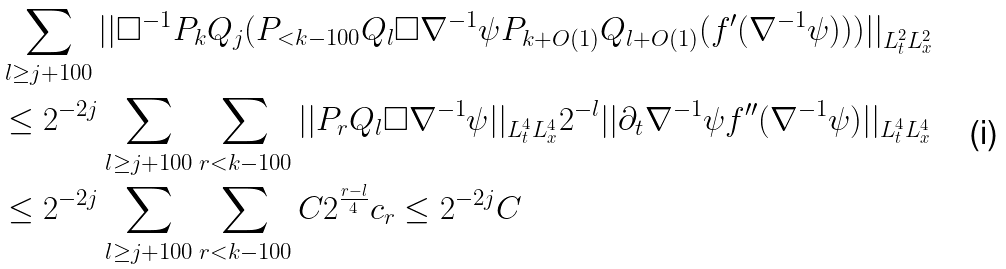<formula> <loc_0><loc_0><loc_500><loc_500>& \sum _ { l \geq j + 1 0 0 } | | \Box ^ { - 1 } P _ { k } Q _ { j } ( P _ { < k - 1 0 0 } Q _ { l } \Box \nabla ^ { - 1 } \psi P _ { k + O ( 1 ) } Q _ { l + O ( 1 ) } ( f ^ { \prime } ( \nabla ^ { - 1 } \psi ) ) ) | | _ { L _ { t } ^ { 2 } L _ { x } ^ { 2 } } \\ & \leq 2 ^ { - 2 j } \sum _ { l \geq j + 1 0 0 } \sum _ { r < k - 1 0 0 } | | P _ { r } Q _ { l } \Box \nabla ^ { - 1 } \psi | | _ { L _ { t } ^ { 4 } L _ { x } ^ { 4 } } 2 ^ { - l } | | \partial _ { t } \nabla ^ { - 1 } \psi f ^ { \prime \prime } ( \nabla ^ { - 1 } \psi ) | | _ { L _ { t } ^ { 4 } L _ { x } ^ { 4 } } \\ & \leq 2 ^ { - 2 j } \sum _ { l \geq j + 1 0 0 } \sum _ { r < k - 1 0 0 } C 2 ^ { \frac { r - l } { 4 } } c _ { r } \leq 2 ^ { - 2 j } C \\</formula> 